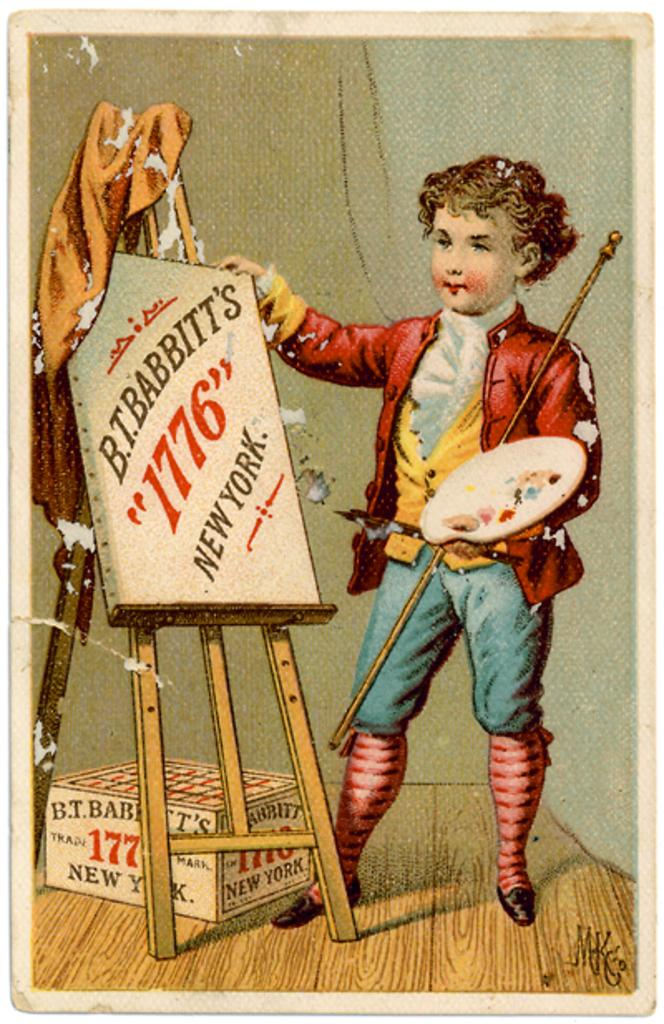What is the main subject of the poster in the image? The poster contains an image of a boy. What is the boy holding in the image? The boy is holding a plate in the image. What objects are in front of the boy in the image? There is a box and a board in front of the boy in the image. How many cushions are on the board in the image? There are no cushions present in the image. 